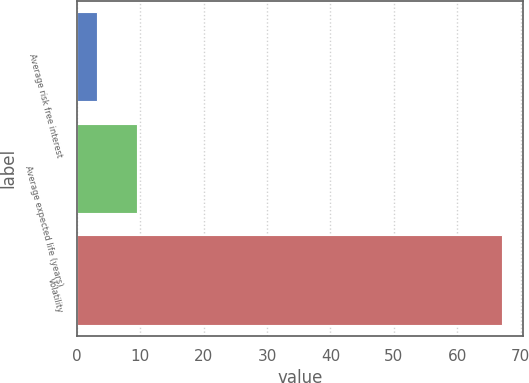<chart> <loc_0><loc_0><loc_500><loc_500><bar_chart><fcel>Average risk free interest<fcel>Average expected life (years)<fcel>Volatility<nl><fcel>3.14<fcel>9.53<fcel>67<nl></chart> 